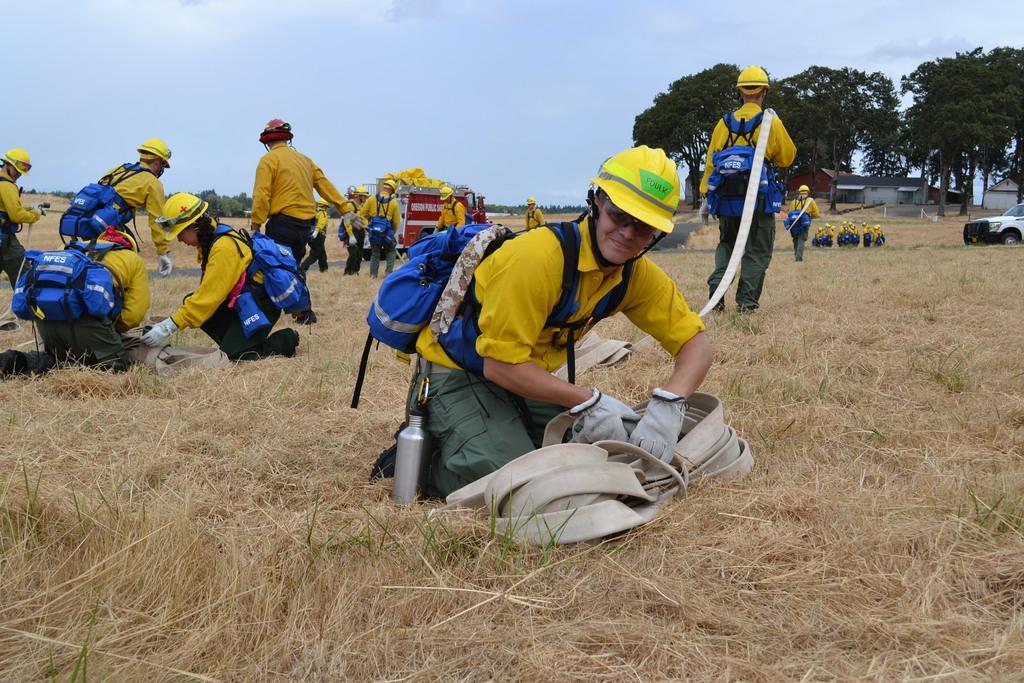Could you give a brief overview of what you see in this image? In this picture there are three persons holding the objects and there are group of people walking. At the back there are vehicles and buildings and trees and there are group of people standing. At the top there is sky and there are clouds. At the bottom there is grass. 